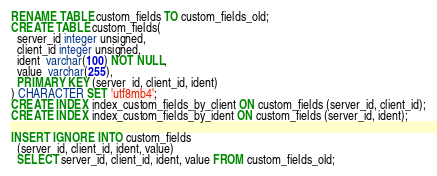Convert code to text. <code><loc_0><loc_0><loc_500><loc_500><_SQL_>RENAME TABLE custom_fields TO custom_fields_old;
CREATE TABLE custom_fields(
  server_id integer unsigned,
  client_id integer unsigned,
  ident  varchar(100) NOT NULL,
  value  varchar(255),
  PRIMARY KEY (server_id, client_id, ident)
) CHARACTER SET 'utf8mb4';
CREATE INDEX index_custom_fields_by_client ON custom_fields (server_id, client_id);
CREATE INDEX index_custom_fields_by_ident ON custom_fields (server_id, ident);

INSERT IGNORE INTO custom_fields
  (server_id, client_id, ident, value)
  SELECT server_id, client_id, ident, value FROM custom_fields_old;
</code> 